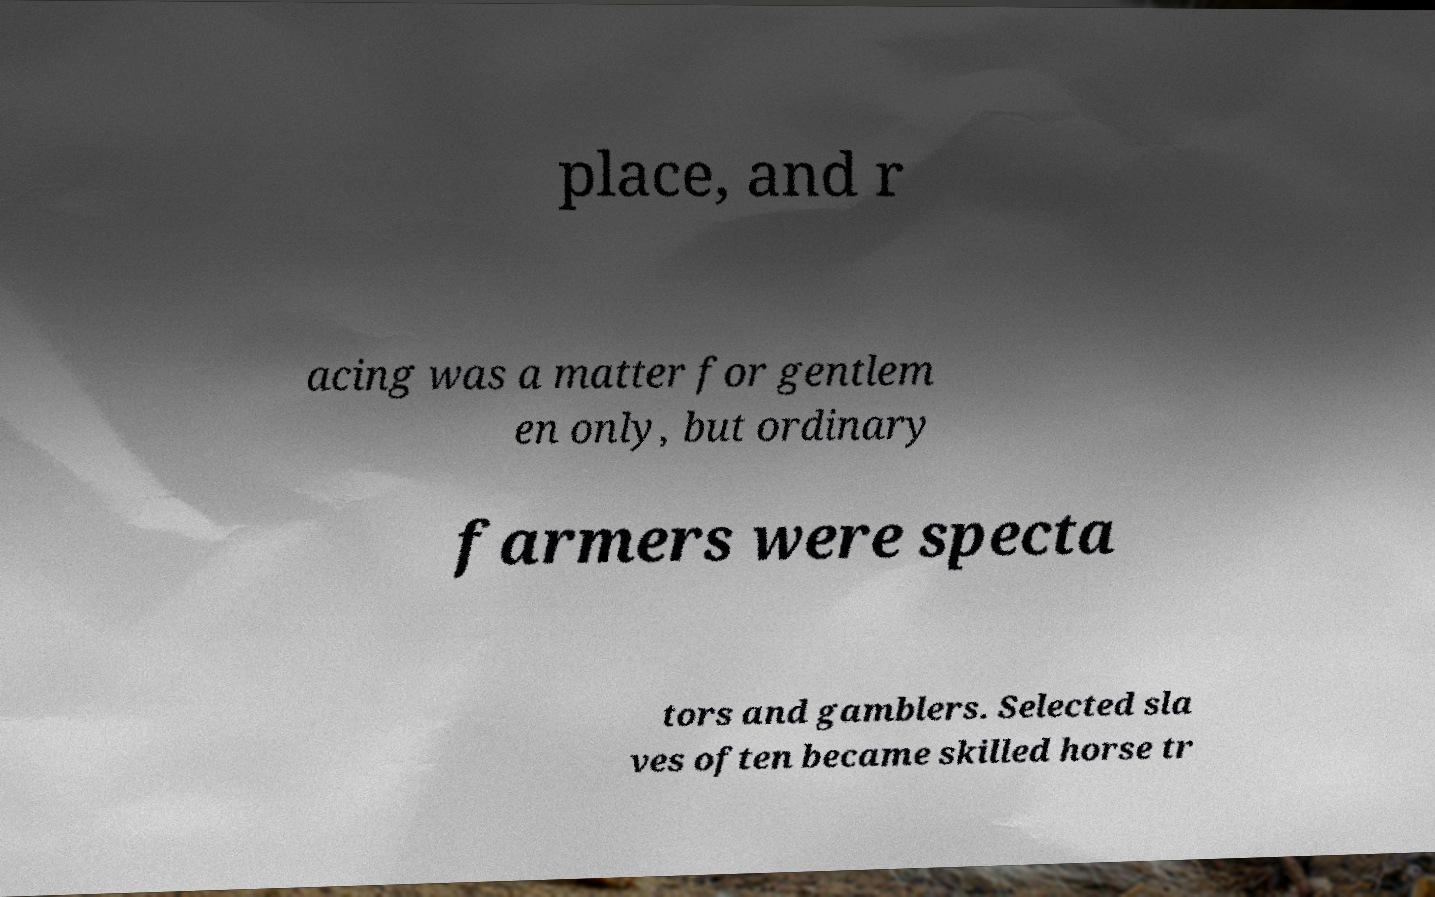Could you assist in decoding the text presented in this image and type it out clearly? place, and r acing was a matter for gentlem en only, but ordinary farmers were specta tors and gamblers. Selected sla ves often became skilled horse tr 